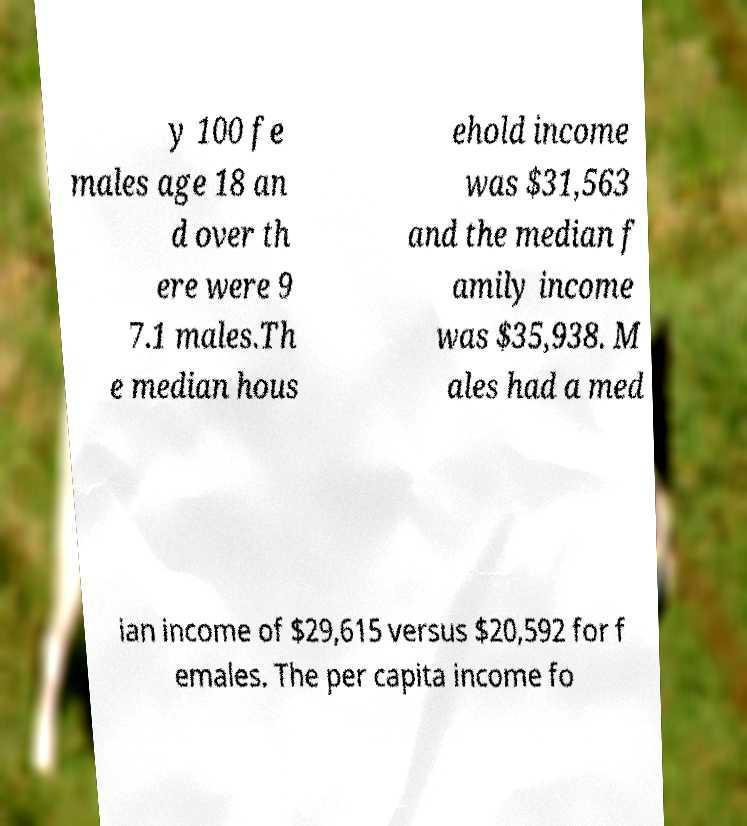What messages or text are displayed in this image? I need them in a readable, typed format. y 100 fe males age 18 an d over th ere were 9 7.1 males.Th e median hous ehold income was $31,563 and the median f amily income was $35,938. M ales had a med ian income of $29,615 versus $20,592 for f emales. The per capita income fo 